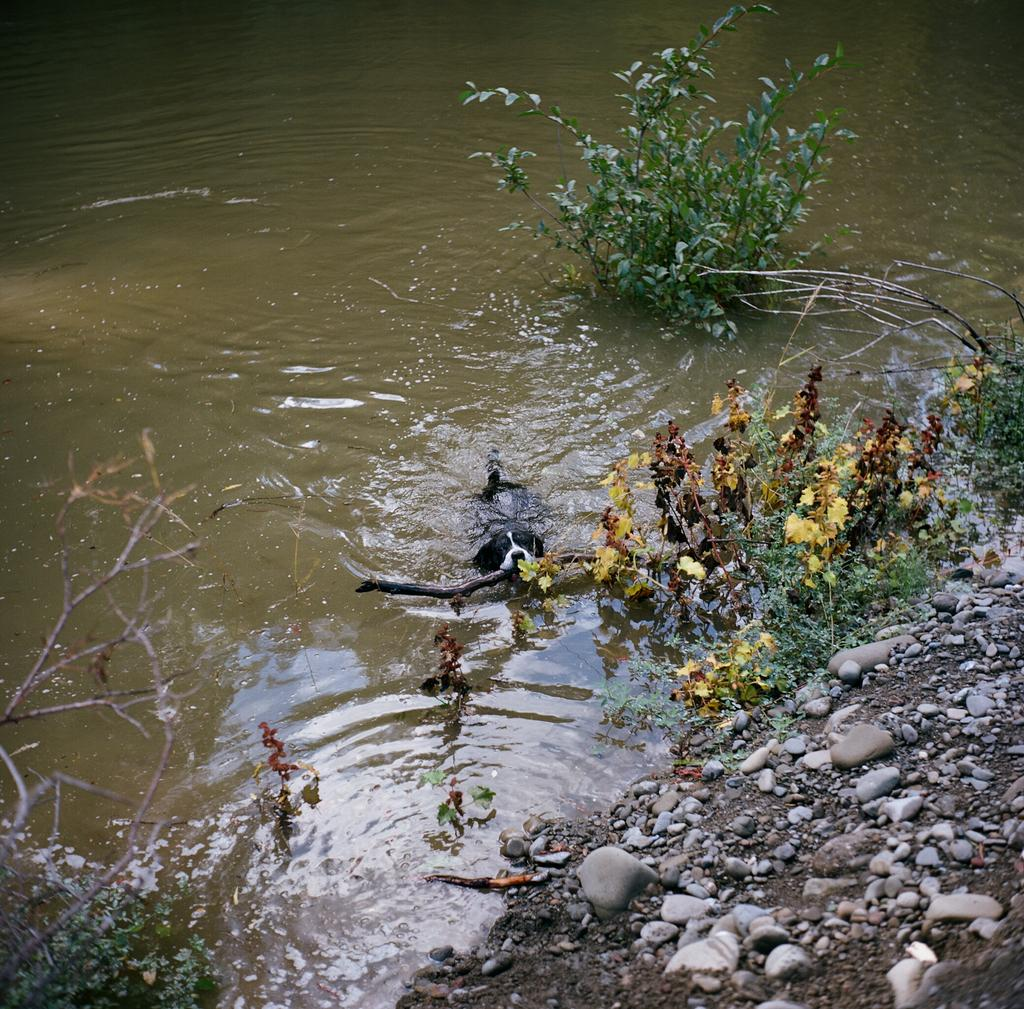What animal is present in the image? There is a dog in the image. What is the dog doing in the image? The dog is diving in water. What type of vegetation can be seen in the image? There are plants visible in the image. Where are the rocks located in the image? The rocks are in the right bottom corner of the image. What type of fowl can be seen attacking the dog in the image? There is no fowl present in the image, nor is there any indication of an attack. 